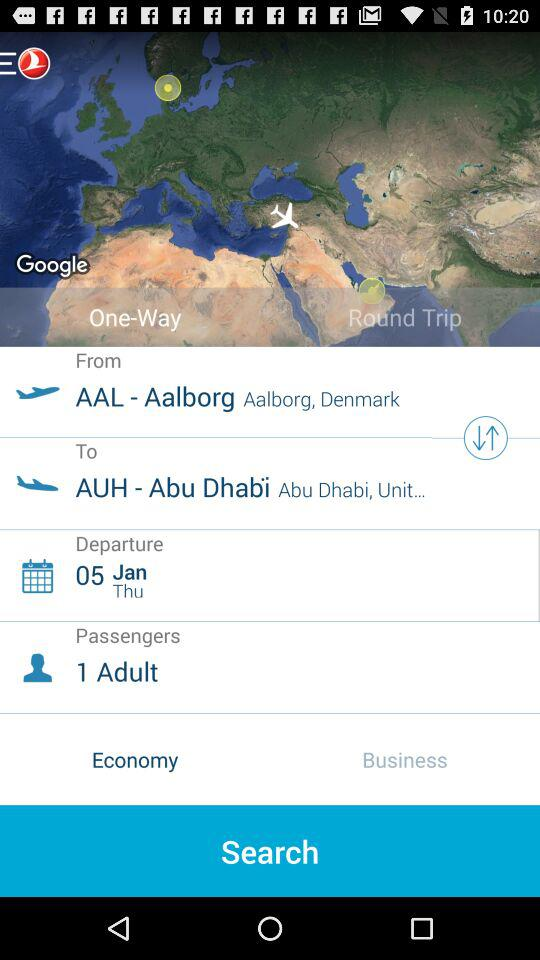What class of ticket is this? This is an economy class ticket. 